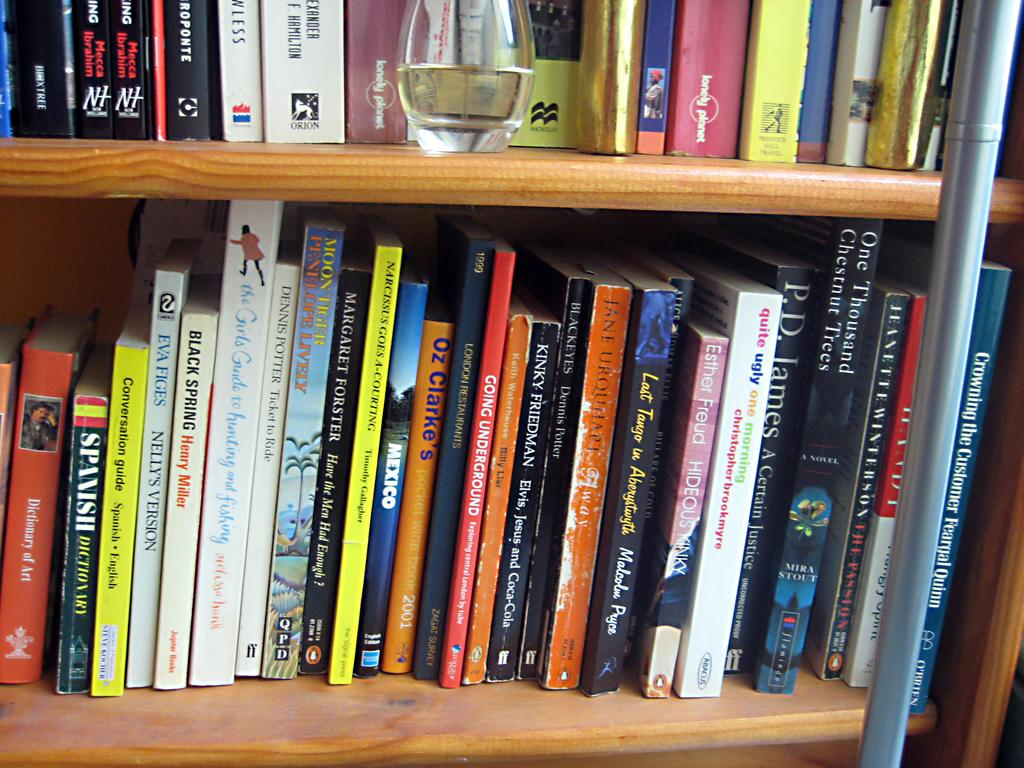What is the main object in the center of the image? There is a bookshelf in the center of the image. Are there any other objects visible in the image? Yes, there is a glass jar in the image. What type of cart is used to transport the books on the bookshelf in the image? There is no cart present in the image, and the books are stationary on the bookshelf. 